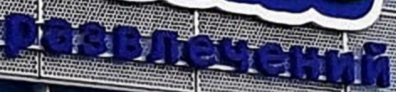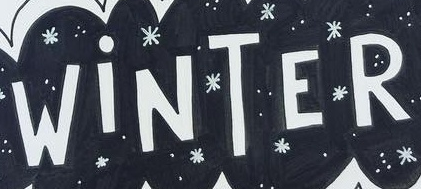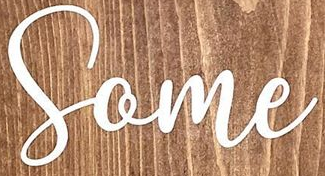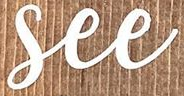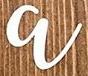Identify the words shown in these images in order, separated by a semicolon. paзвлeчeний; WiNTER; Some; See; a 